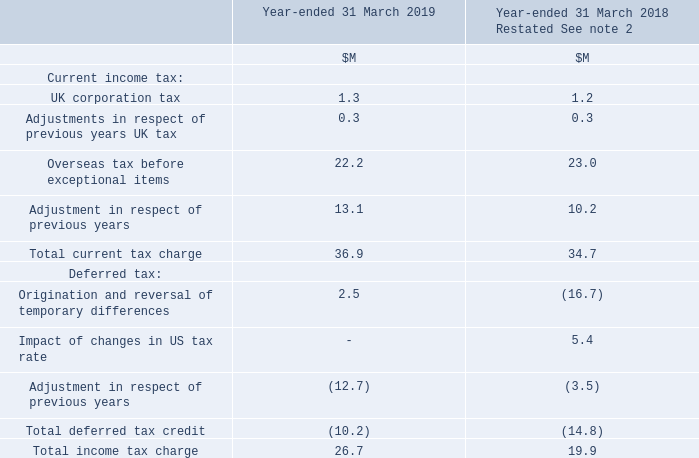14 Taxation
UK corporation tax for the year-ended 31 March 2019 is calculated at 19% (2018: 19%) of the estimated assessable loss for the period.
What was UK corporation tax for the year-ended 31 March 2019 calculated as? 19% (2018: 19%) of the estimated assessable loss for the period. What was the total income tax charge in 2019?
Answer scale should be: million. 26.7. What are the subtotal components in the table used to calculate the total income tax charge? Total current tax charge, total deferred tax credit. In which year was the total income tax charge larger? 26.7>19.9
Answer: 2019. What was the change in Total income tax charge in 2019 from 2018?
Answer scale should be: million. 26.7-19.9
Answer: 6.8. What was the percentage change in Total income tax charge in 2019 from 2018?
Answer scale should be: percent. (26.7-19.9)/19.9
Answer: 34.17. 